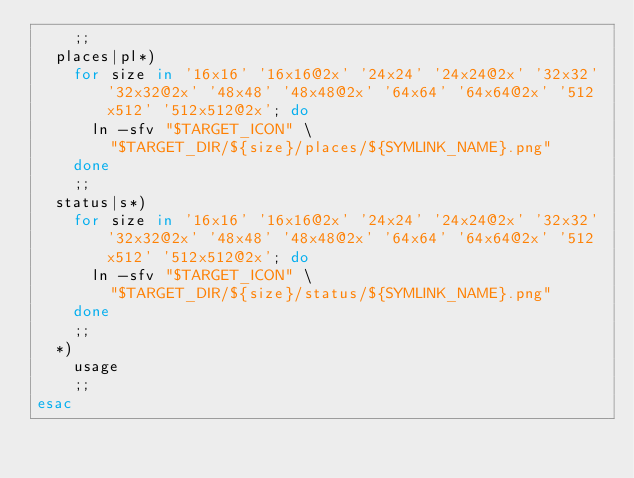<code> <loc_0><loc_0><loc_500><loc_500><_Bash_>		;;
	places|pl*)
		for size in '16x16' '16x16@2x' '24x24' '24x24@2x' '32x32' '32x32@2x' '48x48' '48x48@2x' '64x64' '64x64@2x' '512x512' '512x512@2x'; do
			ln -sfv "$TARGET_ICON" \
				"$TARGET_DIR/${size}/places/${SYMLINK_NAME}.png"
		done
		;;
	status|s*)
		for size in '16x16' '16x16@2x' '24x24' '24x24@2x' '32x32' '32x32@2x' '48x48' '48x48@2x' '64x64' '64x64@2x' '512x512' '512x512@2x'; do
			ln -sfv "$TARGET_ICON" \
				"$TARGET_DIR/${size}/status/${SYMLINK_NAME}.png"
		done
		;;
	*)
		usage
		;;
esac
</code> 